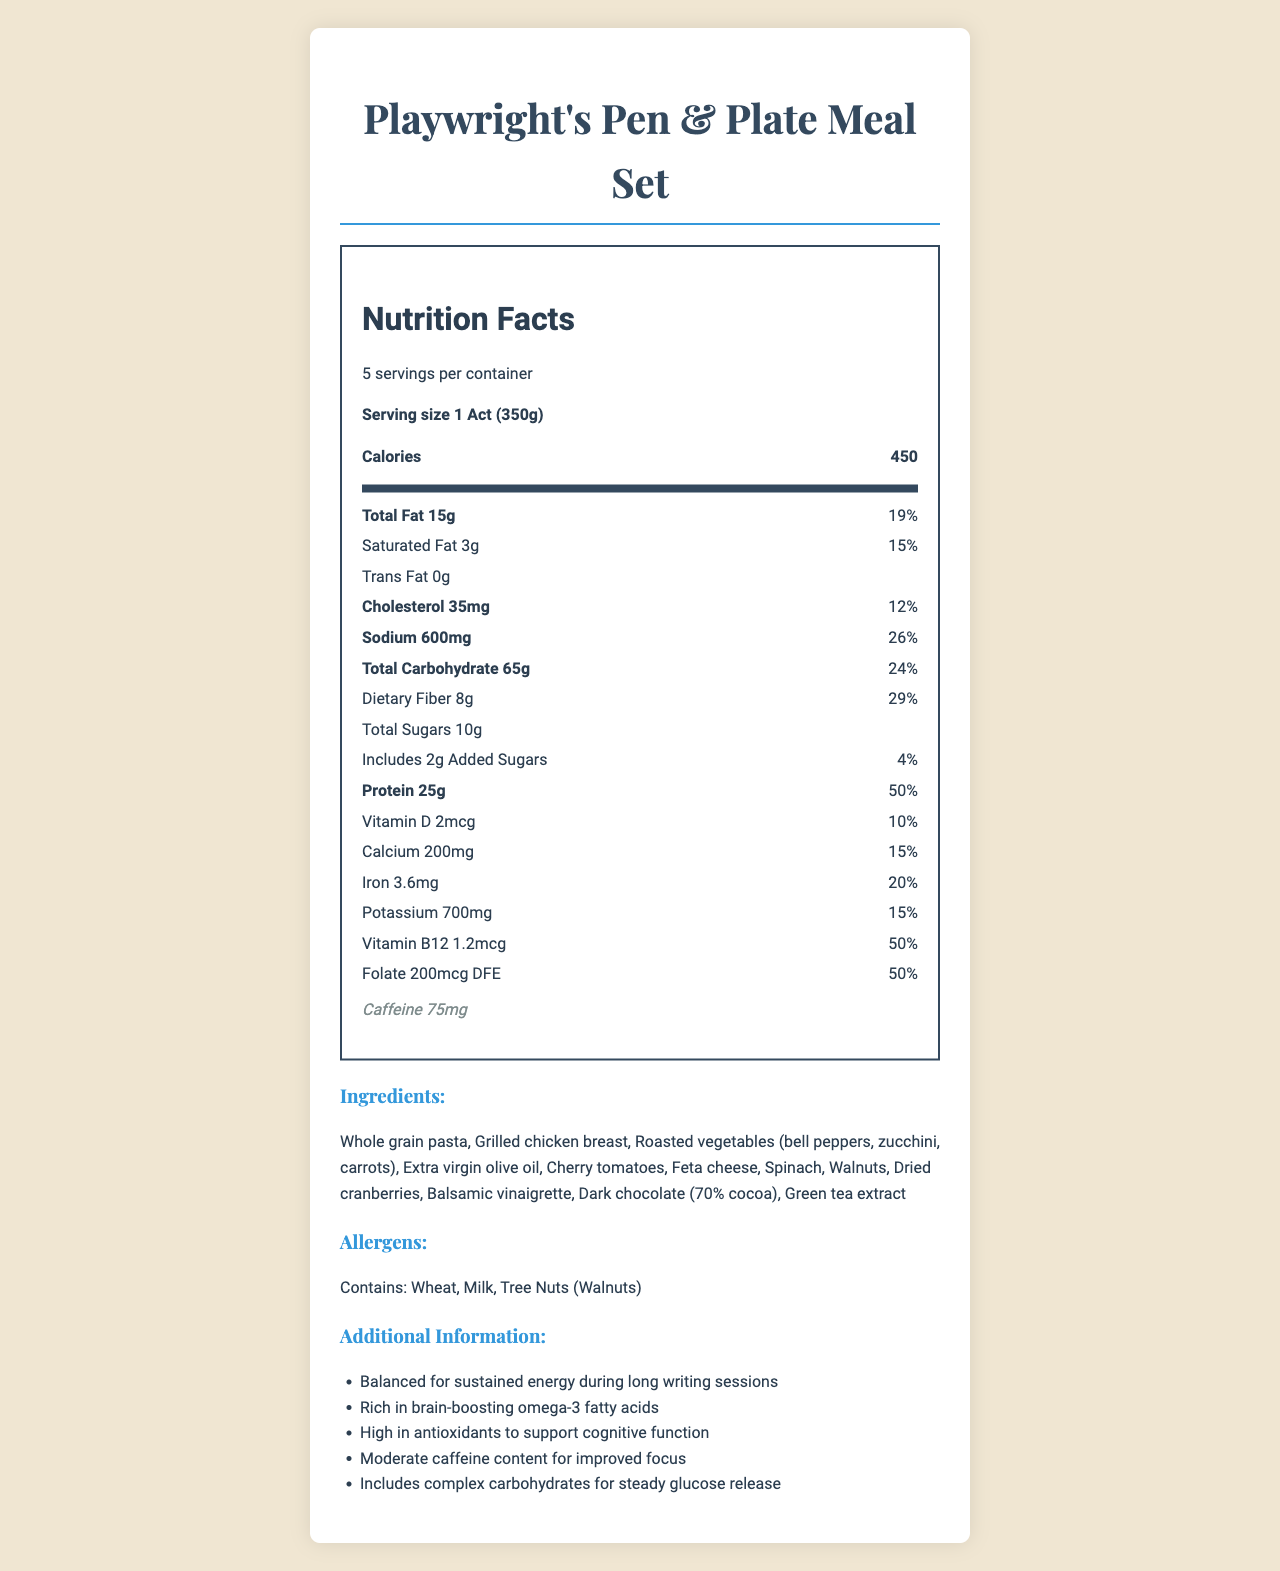what is the serving size of the Playwright's Pen & Plate Meal Set? The document specifies the serving size as "1 Act (350g)".
Answer: 1 Act (350g) how many servings are there per container? The document states that there are 5 servings per container.
Answer: 5 how many calories are there per serving? The document indicates that there are 450 calories per serving.
Answer: 450 what is the total fat content per serving? The total fat content per serving is listed as 15g in the document.
Answer: 15g what are the percentages of daily value for cholesterol and sodium? The document lists the daily values for cholesterol as 12% and for sodium as 26%.
Answer: Cholesterol: 12%, Sodium: 26% what is the main source of protein in the meal? According to the ingredients list, grilled chicken breast is included, which is a significant source of protein.
Answer: Grilled chicken breast how much dietary fiber does one serving contain? The dietary fiber content per serving is 8g as stated in the document.
Answer: 8g Which ingredient is not part of the meal set? A. Spinach B. Walnuts C. Almonds The document lists spinach and walnuts as ingredients, but almonds are not mentioned.
Answer: C. Almonds how much caffeine is in the meal set? The document indicates that there is 75mg of caffeine in the meal set.
Answer: 75mg Which vitamin has the highest percentage daily value in the meal? I. Vitamin D II. Vitamin B12 III. Folate The document shows Vitamin B12 with a daily value percentage of 50%, which is the highest among the listed vitamins.
Answer: II. Vitamin B12 Is this meal suitable for someone with a tree nut allergy? The allergens section of the document indicates that the meal contains tree nuts (walnuts).
Answer: No Summarize the main idea of the document regarding Playwright's Pen & Plate Meal Set. The document describes the nutritional content, ingredients, allergens, and additional benefits of the Playwright's Pen & Plate Meal Set. It emphasizes balanced nutrition, brain-boosting components, and sustained energy release for prolonged creative work.
Answer: The Playwright's Pen & Plate Meal Set is a portion-controlled meal designed for long writing sessions. It provides balanced nutrition with specific ingredients to boost energy, cognitive function, and focus. The meal offers significant protein, dietary fiber, and moderate caffeine, while being mindful of allergens such as wheat, milk, and tree nuts. What is the percentage daily value of iron in one serving? The document specifies that the percentage daily value of iron in one serving is 20%.
Answer: 20% What are the complex carbohydrates included in the meal set? A. Cherry tomatoes B. Whole grain pasta C. Dark chocolate The document mentions whole grain pasta as an ingredient, which is a source of complex carbohydrates.
Answer: B. Whole grain pasta What is the daily value of added sugars in the meal set? The document details that the added sugars account for 4% of the daily value.
Answer: 4% What is the total amount of sugar present in one serving? The document states that the total sugars per serving are 10g.
Answer: 10g Can the document determine the exact amount of Vitamin C in the meal? The document does not provide information about the amount of Vitamin C present in the meal.
Answer: Not given What is the nature of fats used in the meal set? According to the ingredients list, extra virgin olive oil is used, indicative of healthy fats.
Answer: Extra virgin olive oil List one health benefit mentioned in the additional information section. The additional information section mentions that the meal is rich in brain-boosting omega-3 fatty acids.
Answer: Rich in brain-boosting omega-3 fatty acids 